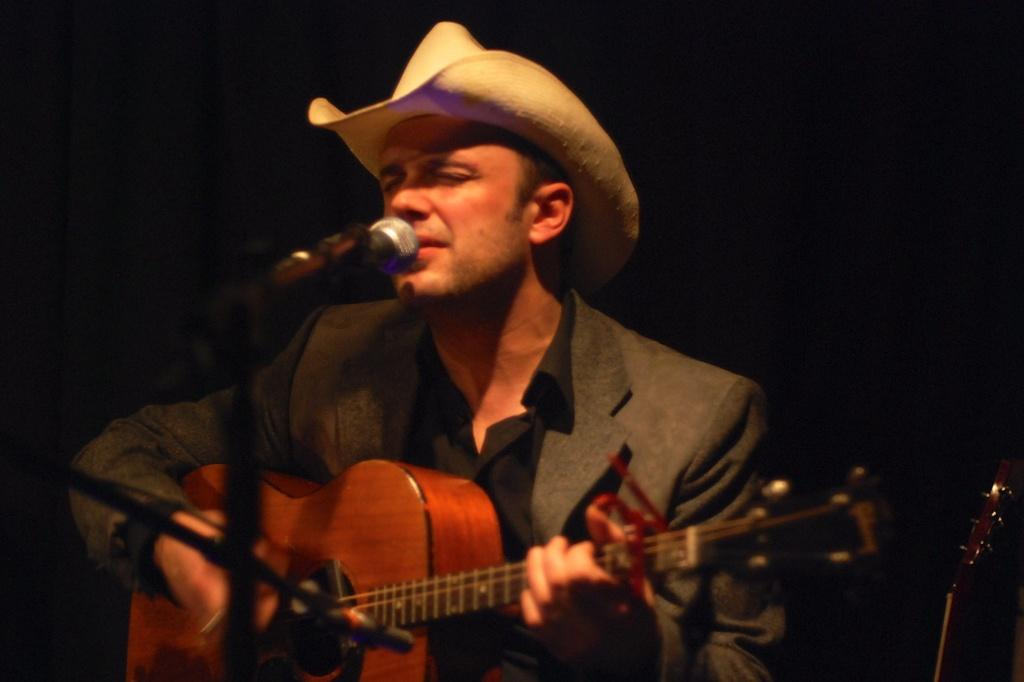What is the man in the image doing? The man is singing in the image. What is the man holding while singing? The man is holding a microphone. What musical instrument is the man playing? The man is playing a guitar. What type of headwear is the man wearing? The man is wearing a hat. What type of drug can be seen in the image? There is no drug present in the image. What branch is the man sitting on in the image? The image does not show the man sitting on a branch; he is standing and playing a guitar. 